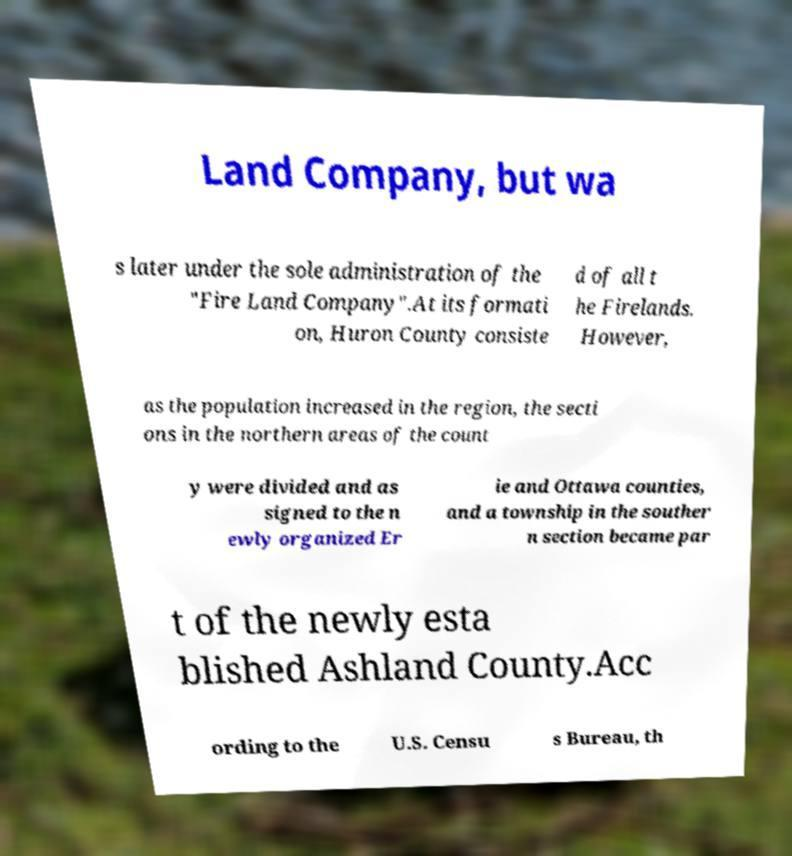Can you read and provide the text displayed in the image?This photo seems to have some interesting text. Can you extract and type it out for me? Land Company, but wa s later under the sole administration of the "Fire Land Company".At its formati on, Huron County consiste d of all t he Firelands. However, as the population increased in the region, the secti ons in the northern areas of the count y were divided and as signed to the n ewly organized Er ie and Ottawa counties, and a township in the souther n section became par t of the newly esta blished Ashland County.Acc ording to the U.S. Censu s Bureau, th 